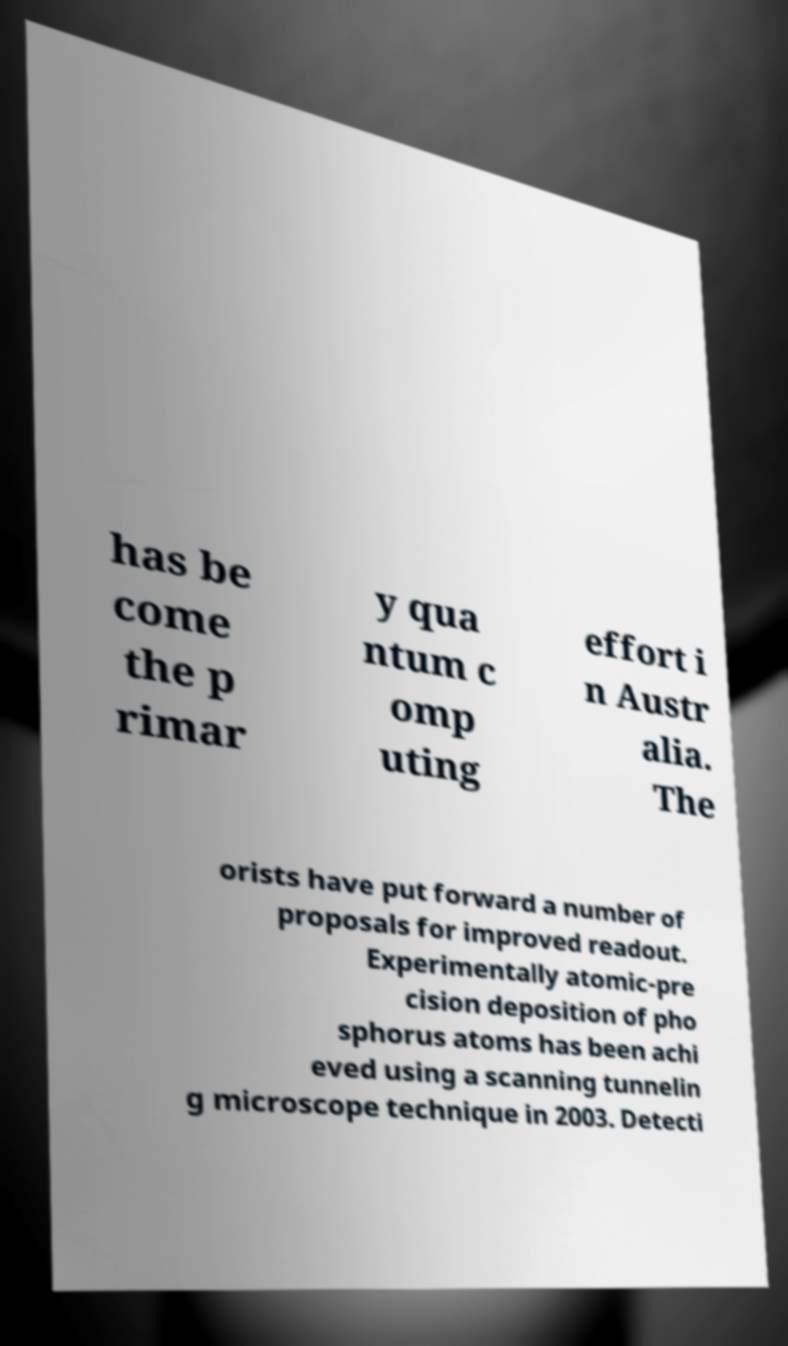Can you accurately transcribe the text from the provided image for me? has be come the p rimar y qua ntum c omp uting effort i n Austr alia. The orists have put forward a number of proposals for improved readout. Experimentally atomic-pre cision deposition of pho sphorus atoms has been achi eved using a scanning tunnelin g microscope technique in 2003. Detecti 